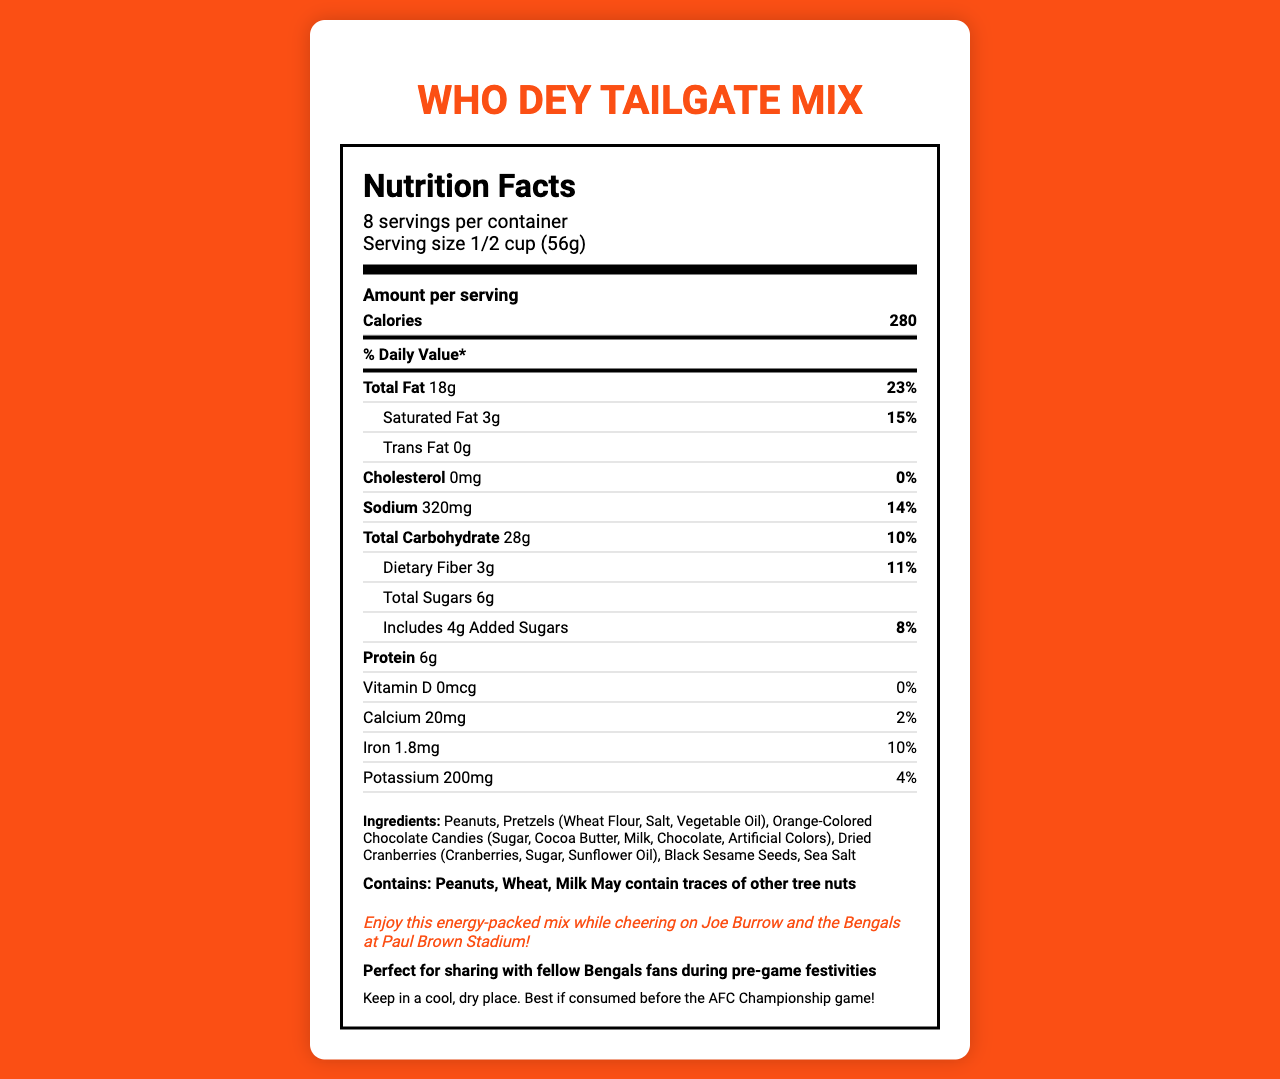what is the serving size? The serving size is stated in the serving info section of the nutrition label as 1/2 cup (56g).
Answer: 1/2 cup (56g) how many servings per container are there? The number of servings per container is mentioned just below the product name on the nutrition label.
Answer: 8 how many calories are in one serving? This information is found under the "Amount per serving" section, where it lists the number of calories per serving.
Answer: 280 what is the total fat content per serving? The total fat content is listed in the nutrient breakdown section as 18g.
Answer: 18g what is the percentage of daily value for sodium? This value is listed next to the sodium content in the nutrient breakdown section.
Answer: 14% which ingredients are allergens? A. Peanuts B. Pretzels C. Orange-Colored Chocolate Candies D. All of the above The allergen information mentions that the product contains Peanuts, Wheat (in Pretzels), and Milk (in Orange-Colored Chocolate Candies).
Answer: D. All of the above how much protein is there per serving? A. 3g B. 6g C. 9g D. 12g The protein amount per serving is listed as 6g in the nutrient breakdown section.
Answer: B. 6g does this product contain any trans fat? The nutrient breakdown section states that the trans fat amount is 0g.
Answer: No is this snack mix suitable for people with a tree nut allergy? Although the allergen statement indicates the product contains peanuts, it also states that it may contain traces of other tree nuts.
Answer: Not necessarily summarize the main idea of this document. The document is a detailed nutrition facts label for "Who Dey Tailgate Mix" that includes serving size, calories, fat, protein, carbohydrates, and other nutrients. It also lists ingredients, allergens, and special notes for Bengals fans.
Answer: The document provides the nutrition facts for the "Who Dey Tailgate Mix," a snack mix ideal for Cincinnati Bengals fans. It includes information on serving size, calories, macronutrients, and daily values, along with ingredient lists, allergen warnings, and special notes for Bengals fans to enjoy the mix during pre-game festivities. does this product have any dietary fiber? The nutrient breakdown section indicates that the product contains 3g of dietary fiber per serving.
Answer: Yes what are the first three ingredients listed? The ingredients section lists Peanuts, Pretzels, and Orange-Colored Chocolate Candies as the first three ingredients.
Answer: Peanuts, Pretzels, Orange-Colored Chocolate Candies what is the product's special note for Bengals fans? This note is found at the end of the document in italics, stressing the fun and festive nature of the snack mix for Bengals fans.
Answer: "Enjoy this energy-packed mix while cheering on Joe Burrow and the Bengals at Paul Brown Stadium!" can you determine the exact amount of vitamin D in the product? The nutrient breakdown section indicates that the product contains 0 mcg of vitamin D per serving.
Answer: 0 mcg what is the total carbohydrate content per serving? This information is found in the nutrient breakdown section, where it lists the total carbohydrate content as 28g per serving.
Answer: 28g is the storage recommendation to keep this product in a warm place? The storage instructions recommend keeping it in a cool, dry place.
Answer: No what is the tailgate serving instruction for this product? This is listed near the end of the document under tailgate serving instructions.
Answer: "Perfect for sharing with fellow Bengals fans during pre-game festivities" how much iron does one serving contain? The amount of iron per serving is listed as 1.8mg in the nutrient breakdown section.
Answer: 1.8mg how many grams of added sugars are included in one serving? The amount of added sugars is listed as 4g in the nutrient breakdown section.
Answer: 4g is there a cholesterol content per serving? The nutrient breakdown section states that the cholesterol amount is 0mg per serving.
Answer: No how many mg of potassium does the product contain per serving? The potassium content per serving is listed as 200mg in the nutrient breakdown section.
Answer: 200mg what is the main ingredient in the tailgate mix? The ingredients list starts with Peanuts, indicating it's the main ingredient.
Answer: Peanuts is there any information about the fiber source in the product? The document does not specify the source of the dietary fiber.
Answer: Cannot be determined how many grams of total sugars are there per serving? The total sugars per serving is listed as 6g in the nutrient breakdown section.
Answer: 6g 